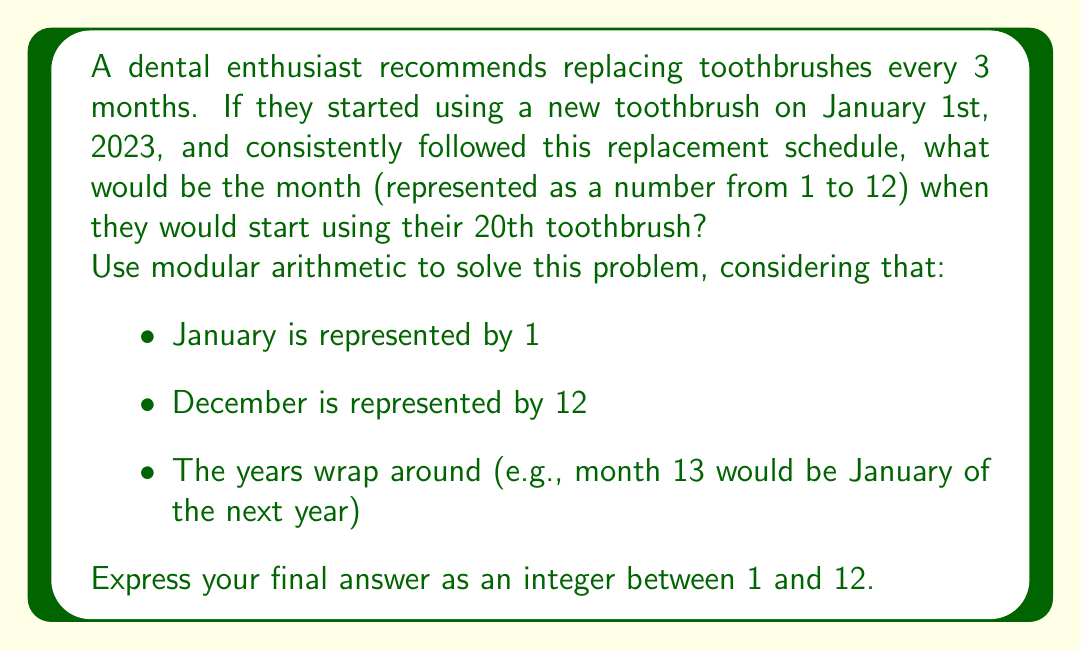Show me your answer to this math problem. Let's approach this step-by-step using modular arithmetic:

1) First, let's calculate how many months will pass before the 20th toothbrush is used:
   $$(20 - 1) \times 3 = 57$$ months
   (We subtract 1 because the first toothbrush is used immediately)

2) Now, we need to find what month we'll be in after 57 months have passed since January (month 1).

3) In modular arithmetic, we can represent this as:
   $$(1 + 57) \bmod 12$$

4) Simplify:
   $$58 \bmod 12$$

5) To calculate this:
   $$58 = 4 \times 12 + 10$$
   Therefore, $$58 \bmod 12 = 10$$

6) In our month numbering system, 10 represents October.

Thus, the 20th toothbrush will be started in October.
Answer: 10 